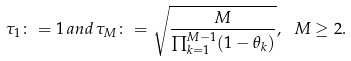Convert formula to latex. <formula><loc_0><loc_0><loc_500><loc_500>\tau _ { 1 } \colon = 1 \, a n d \, \tau _ { M } \colon = \sqrt { \frac { M } { \prod _ { k = 1 } ^ { M - 1 } ( 1 - \theta _ { k } ) } } , \ M \geq 2 .</formula> 